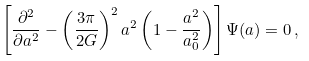Convert formula to latex. <formula><loc_0><loc_0><loc_500><loc_500>\left [ \frac { \partial ^ { 2 } } { \partial a ^ { 2 } } - \left ( \frac { 3 \pi } { 2 G } \right ) ^ { 2 } a ^ { 2 } \left ( 1 - \frac { a ^ { 2 } } { a _ { 0 } ^ { 2 } } \right ) \right ] \Psi ( a ) = 0 \, ,</formula> 